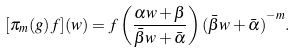Convert formula to latex. <formula><loc_0><loc_0><loc_500><loc_500>[ \pi _ { m } ( g ) f ] ( w ) = f \left ( \frac { \alpha w + \beta } { \bar { \beta } w + \bar { \alpha } } \right ) { ( \bar { \beta } w + \bar { \alpha } ) } ^ { - m } .</formula> 